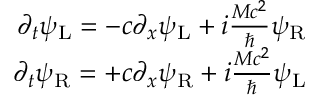<formula> <loc_0><loc_0><loc_500><loc_500>\begin{array} { r } { \partial _ { t } \psi _ { L } = - c \partial _ { x } \psi _ { L } + i \frac { M c ^ { 2 } } { } \psi _ { R } } \\ { \partial _ { t } \psi _ { R } = + c \partial _ { x } \psi _ { R } + i \frac { M c ^ { 2 } } { } \psi _ { L } } \end{array}</formula> 